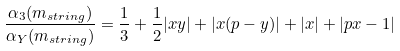<formula> <loc_0><loc_0><loc_500><loc_500>\frac { \alpha _ { 3 } ( m _ { s t r i n g } ) } { \alpha _ { Y } ( m _ { s t r i n g } ) } = \frac { 1 } { 3 } + \frac { 1 } { 2 } | x y | + | x ( p - y ) | + | x | + | p x - 1 |</formula> 